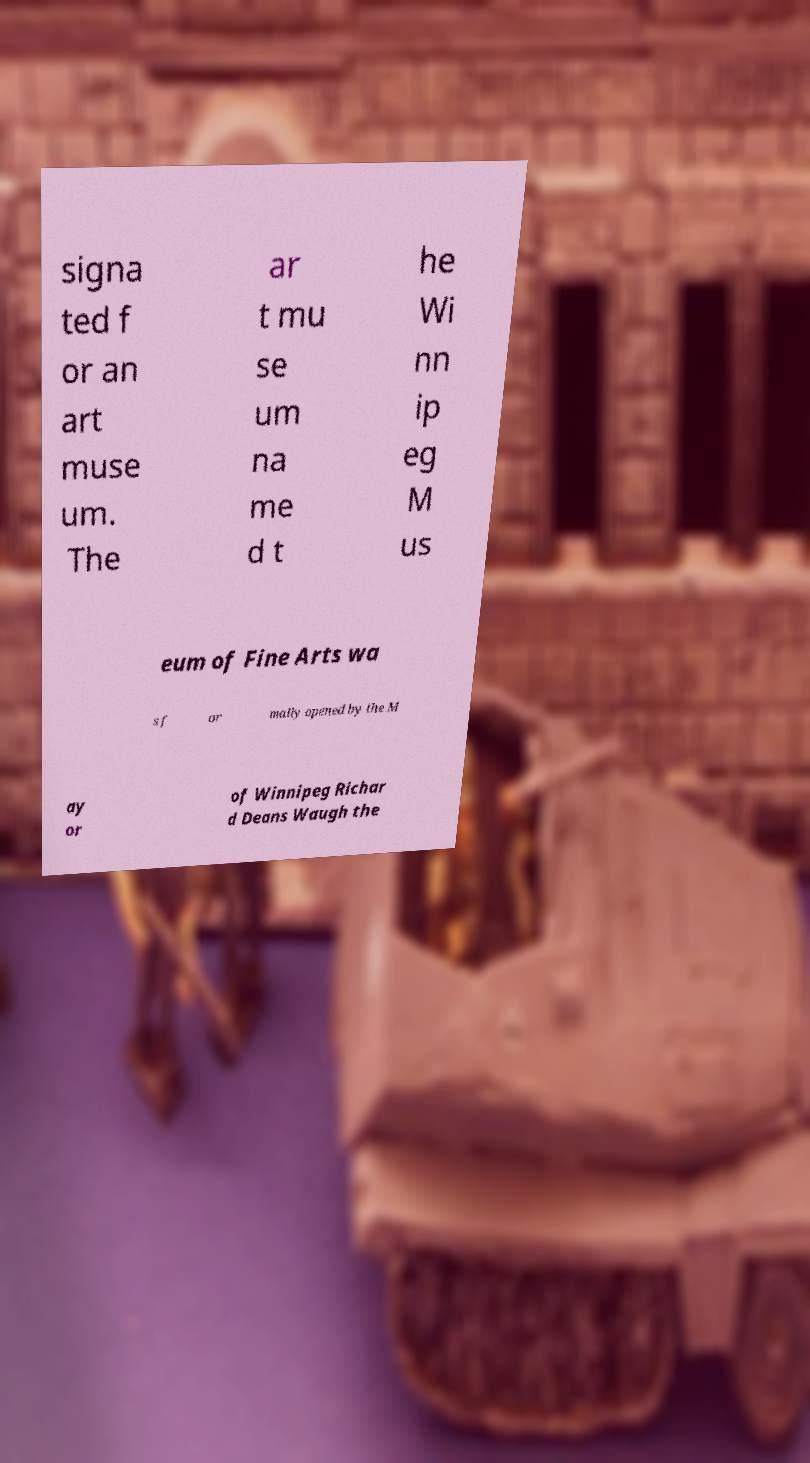Please read and relay the text visible in this image. What does it say? signa ted f or an art muse um. The ar t mu se um na me d t he Wi nn ip eg M us eum of Fine Arts wa s f or mally opened by the M ay or of Winnipeg Richar d Deans Waugh the 